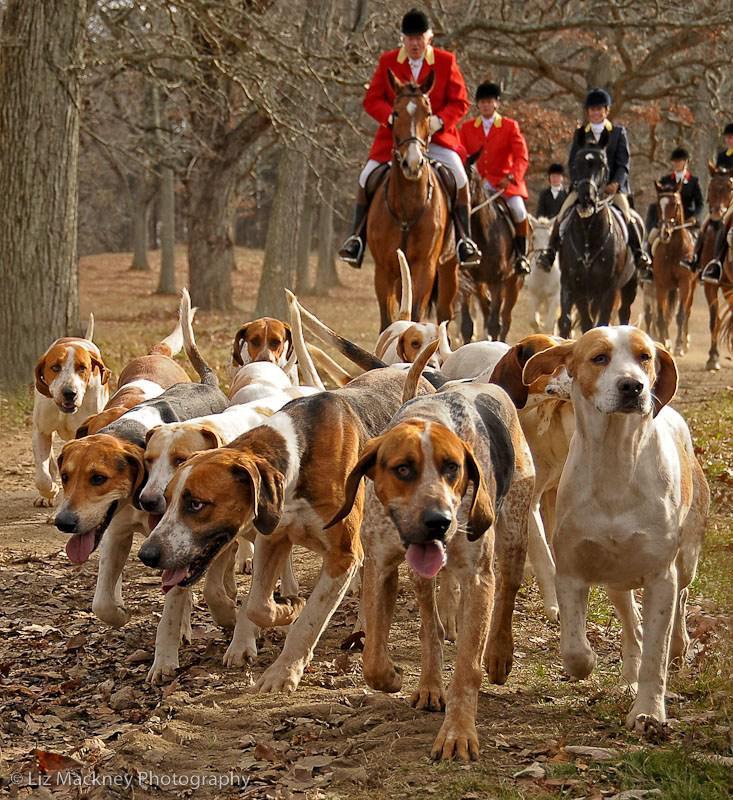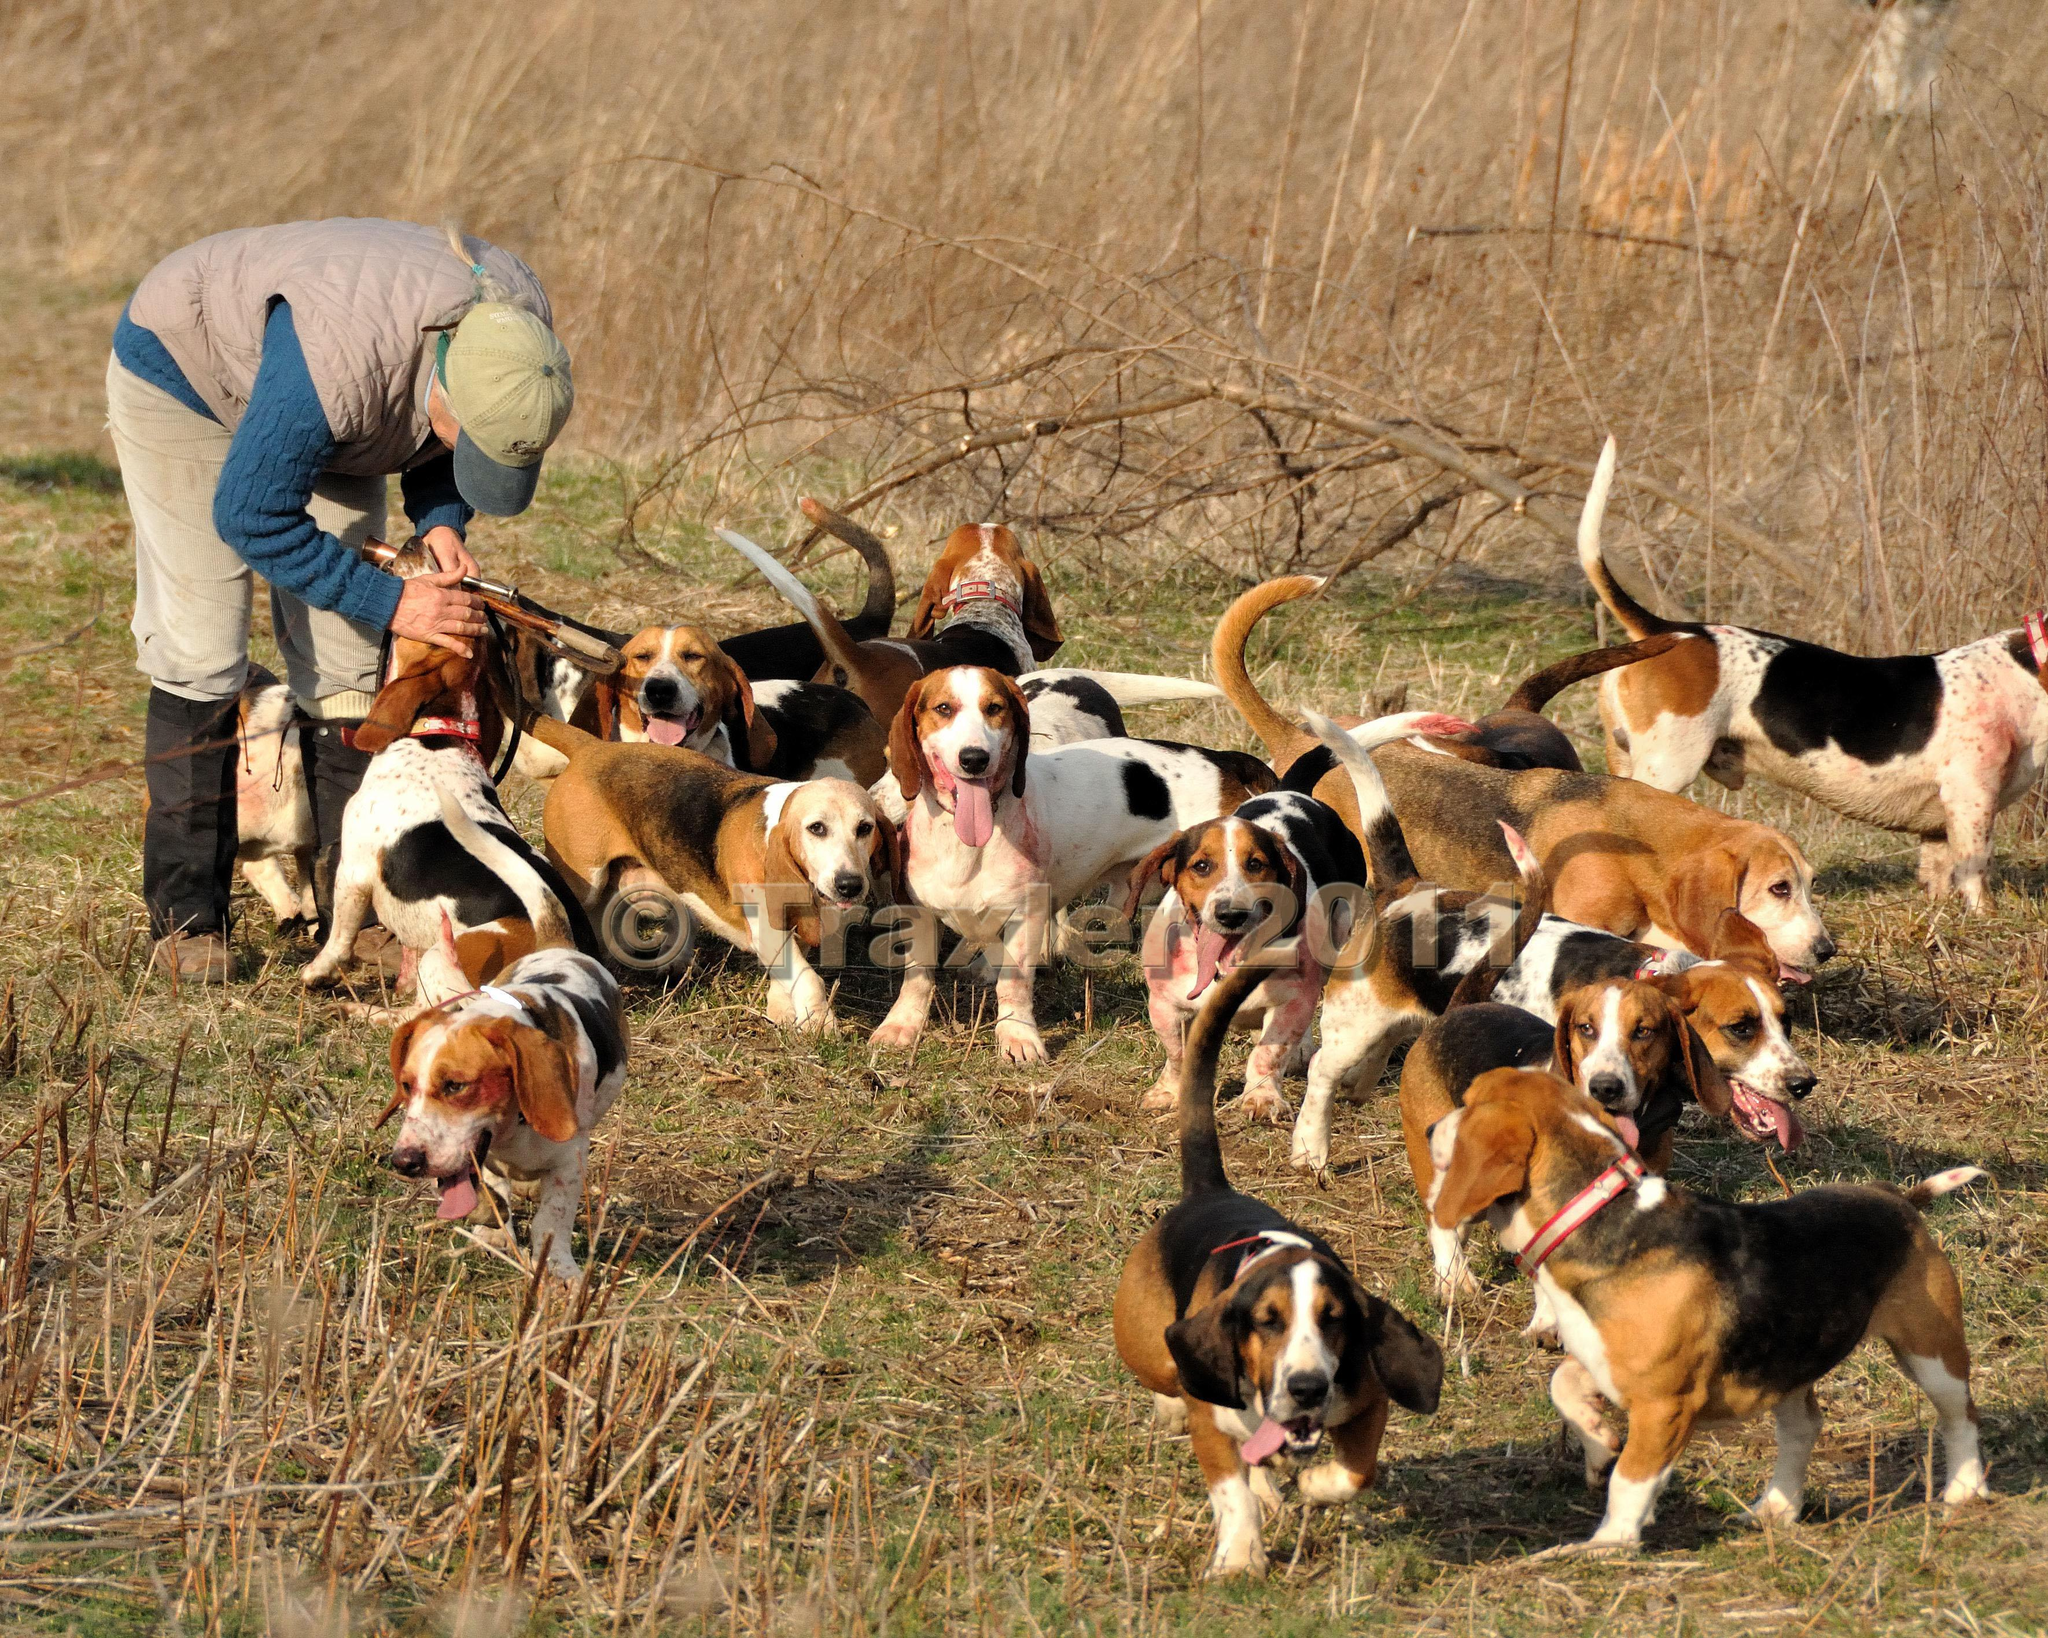The first image is the image on the left, the second image is the image on the right. Examine the images to the left and right. Is the description "There are exactly two animals in the image on the left." accurate? Answer yes or no. No. 